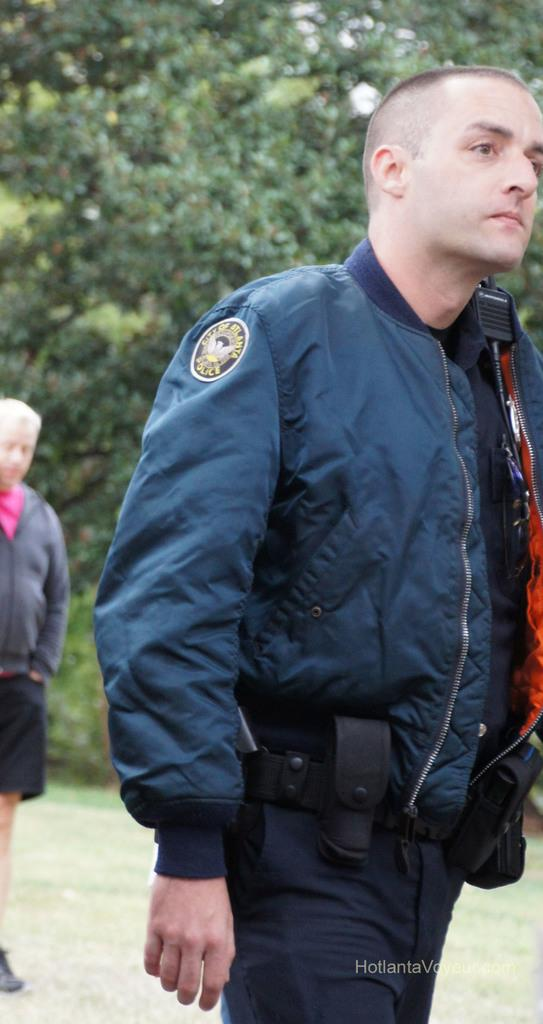What is the main subject in the foreground of the image? There is a person in the foreground of the image. Can you describe the background of the image? There is another person and trees in the background of the image. What type of vegetation is visible at the bottom of the image? There is grass at the bottom of the image. What type of stocking is the airplane wearing in the image? There is no airplane present in the image, and therefore no stocking or airplane can be observed. 